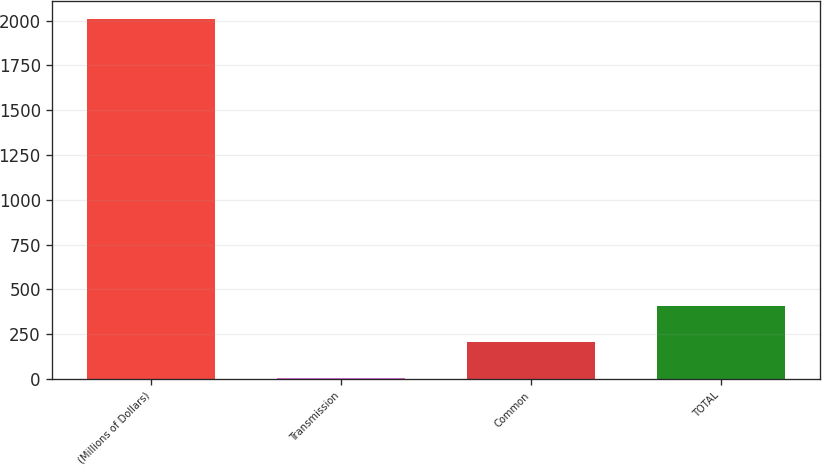Convert chart to OTSL. <chart><loc_0><loc_0><loc_500><loc_500><bar_chart><fcel>(Millions of Dollars)<fcel>Transmission<fcel>Common<fcel>TOTAL<nl><fcel>2008<fcel>5<fcel>205.3<fcel>405.6<nl></chart> 